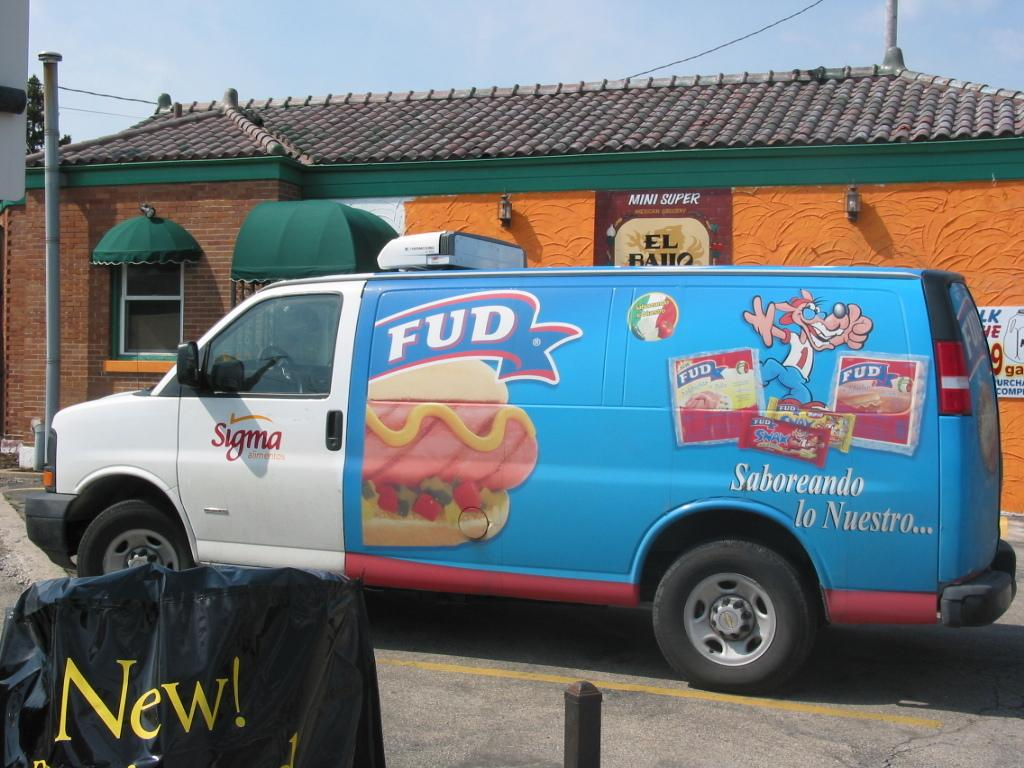Provide a one-sentence caption for the provided image. The delivery truck logo says FUD and it is blue. 